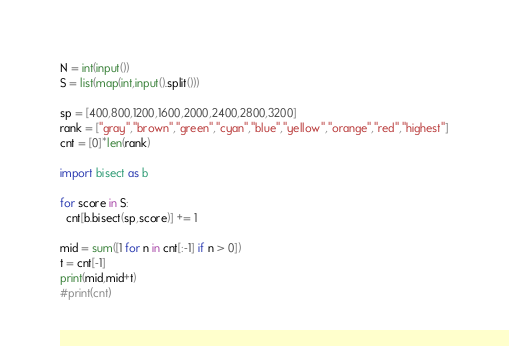Convert code to text. <code><loc_0><loc_0><loc_500><loc_500><_Python_>N = int(input())
S = list(map(int,input().split()))

sp = [400,800,1200,1600,2000,2400,2800,3200]
rank = ["gray","brown","green","cyan","blue","yellow","orange","red","highest"]
cnt = [0]*len(rank)

import bisect as b

for score in S:
  cnt[b.bisect(sp,score)] += 1
  
mid = sum([1 for n in cnt[:-1] if n > 0])
t = cnt[-1]
print(mid,mid+t)
#print(cnt)</code> 